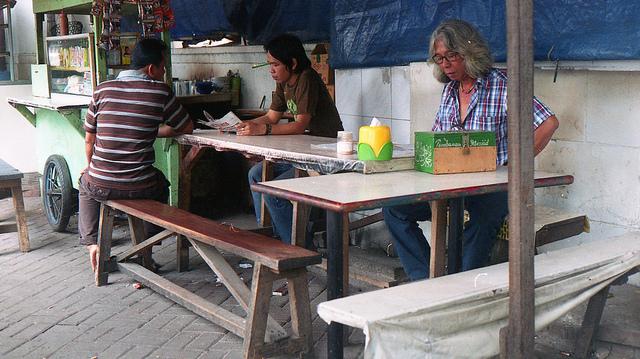Is this a fancy eatery?
Keep it brief. No. Is this outside?
Quick response, please. Yes. What color hair does the person in plaid have?
Be succinct. Gray. 